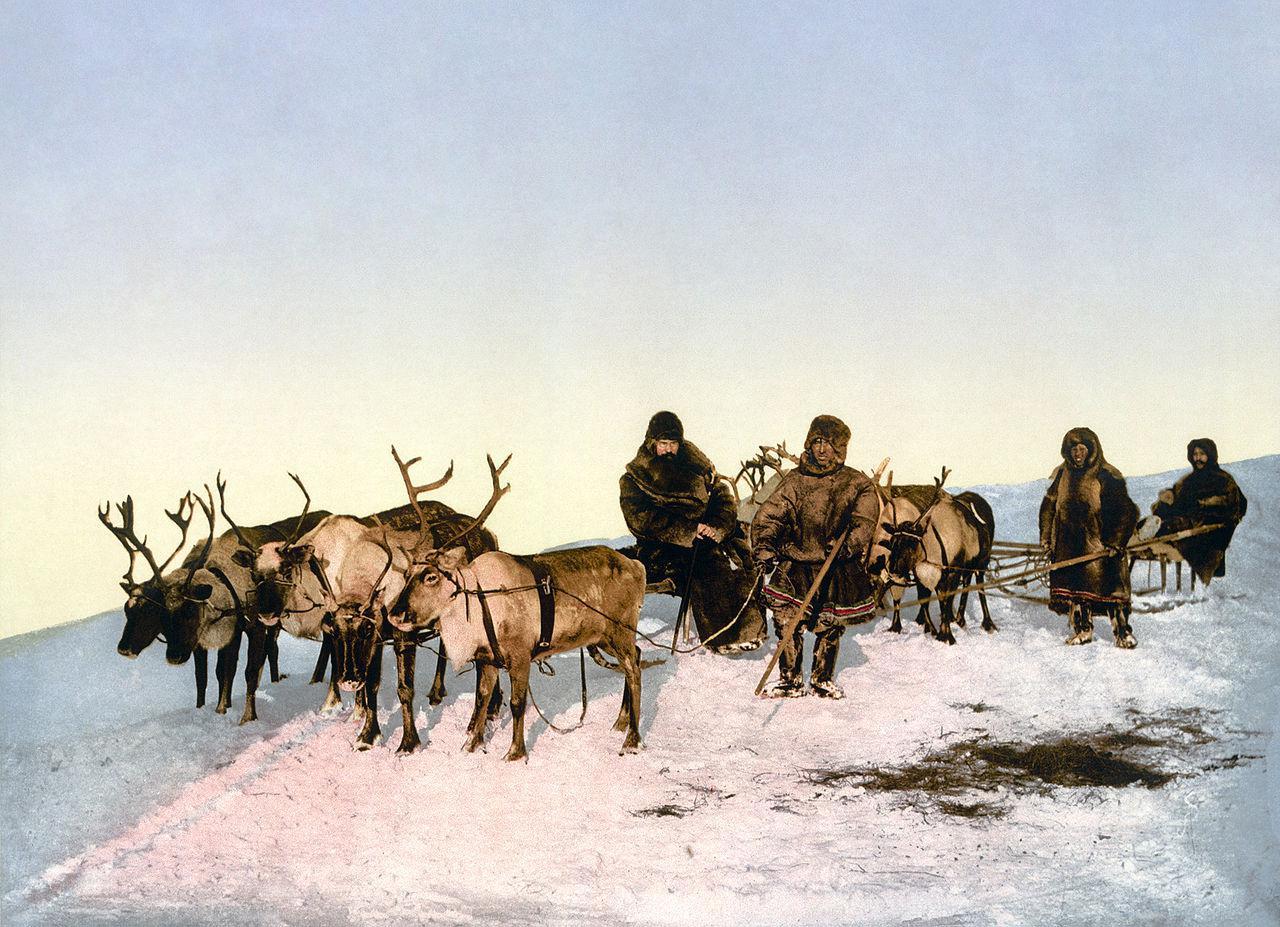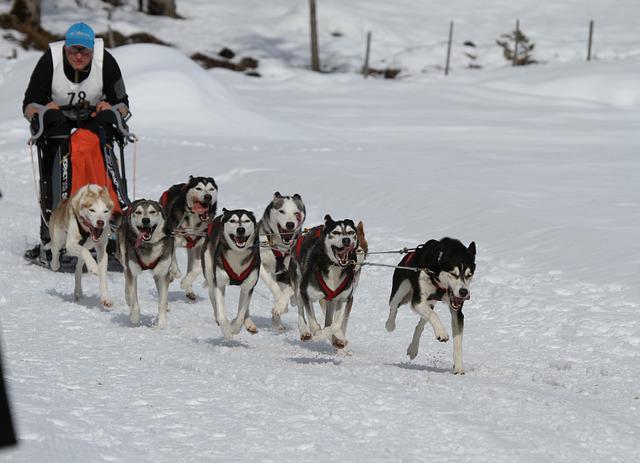The first image is the image on the left, the second image is the image on the right. Analyze the images presented: Is the assertion "The sled in the image on the left is unoccupied." valid? Answer yes or no. No. The first image is the image on the left, the second image is the image on the right. Evaluate the accuracy of this statement regarding the images: "In at least one image there is a single female with her hair showing and there are eight dogs attached to a sled.". Is it true? Answer yes or no. No. 